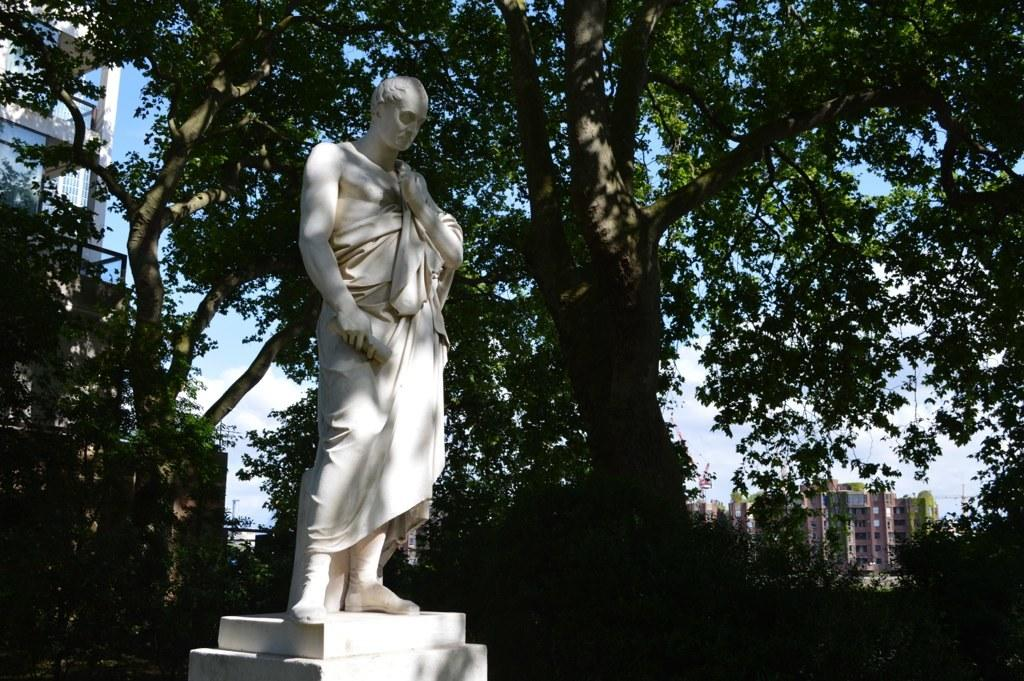What is the main subject in the center of the image? There is a statue in the center of the image. What can be seen in the background of the image? There are trees and buildings in the background of the image. What color is the glove hanging on the tree in the image? There is no glove present in the image. What historical event is depicted in the statue in the image? The image does not provide enough information to determine any historical event depicted in the statue. 